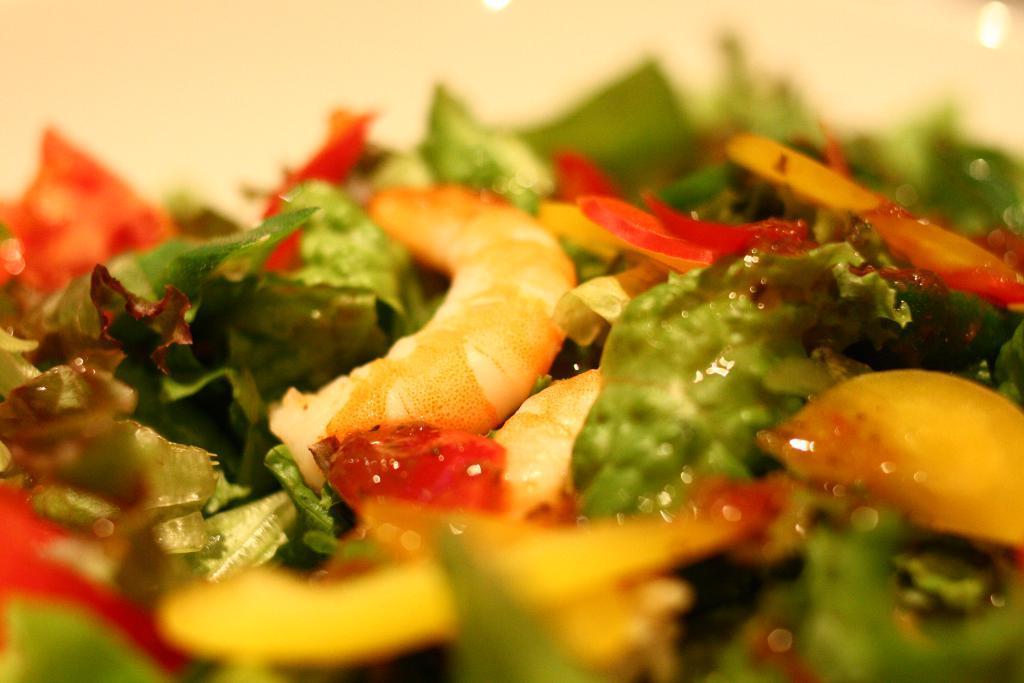Could you give a brief overview of what you see in this image? This picture consists of food items in the center of the image, which contains green leafy vegetables and other items. 